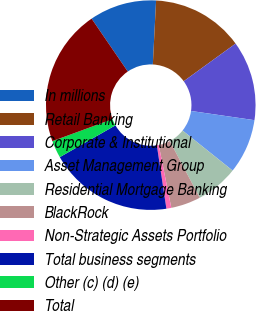<chart> <loc_0><loc_0><loc_500><loc_500><pie_chart><fcel>In millions<fcel>Retail Banking<fcel>Corporate & Institutional<fcel>Asset Management Group<fcel>Residential Mortgage Banking<fcel>BlackRock<fcel>Non-Strategic Assets Portfolio<fcel>Total business segments<fcel>Other (c) (d) (e)<fcel>Total<nl><fcel>10.36%<fcel>14.2%<fcel>12.28%<fcel>8.44%<fcel>6.52%<fcel>4.6%<fcel>0.76%<fcel>19.11%<fcel>2.68%<fcel>21.03%<nl></chart> 